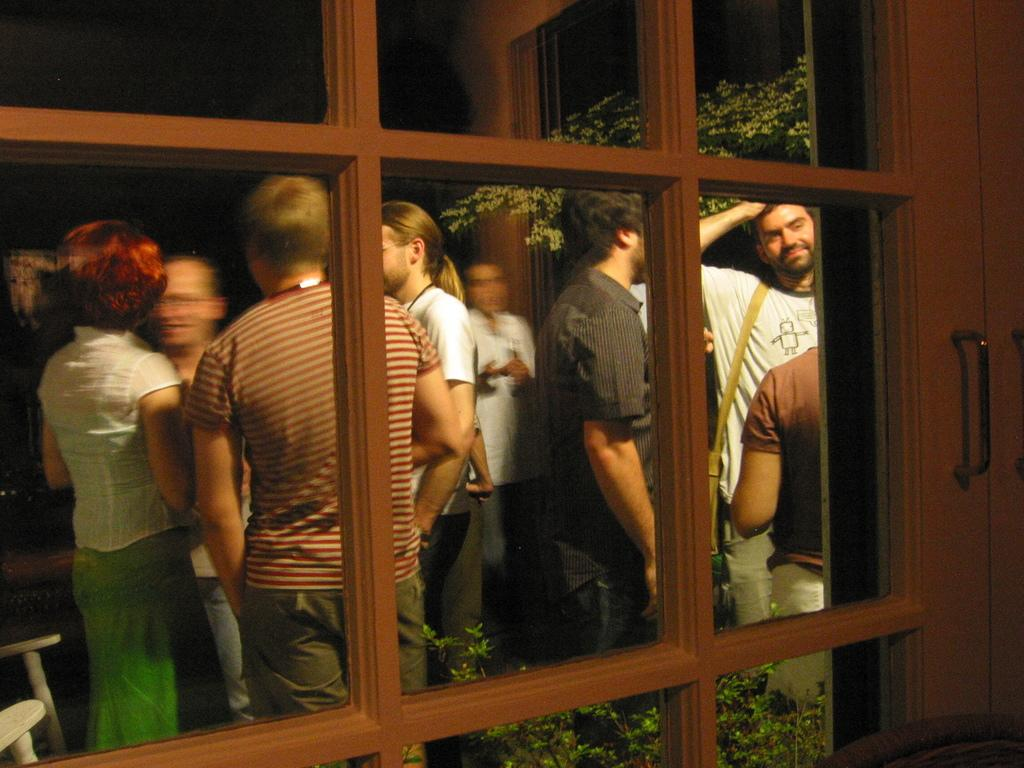What type of object is visible in the image? There is a wooden object in the image. What can be seen in the background of the image? There is a group of people, trees, and some objects in the background of the image. How does the wooden object stop the trick from happening in the image? The wooden object does not stop any trick in the image, as there is no trick or any indication of one in the provided facts. 